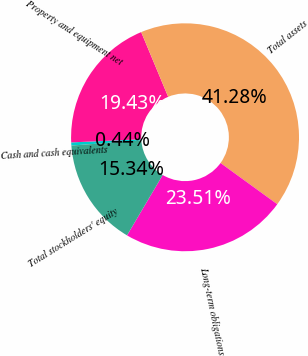Convert chart. <chart><loc_0><loc_0><loc_500><loc_500><pie_chart><fcel>Cash and cash equivalents<fcel>Property and equipment net<fcel>Total assets<fcel>Long-term obligations<fcel>Total stockholders' equity<nl><fcel>0.44%<fcel>19.43%<fcel>41.28%<fcel>23.51%<fcel>15.34%<nl></chart> 